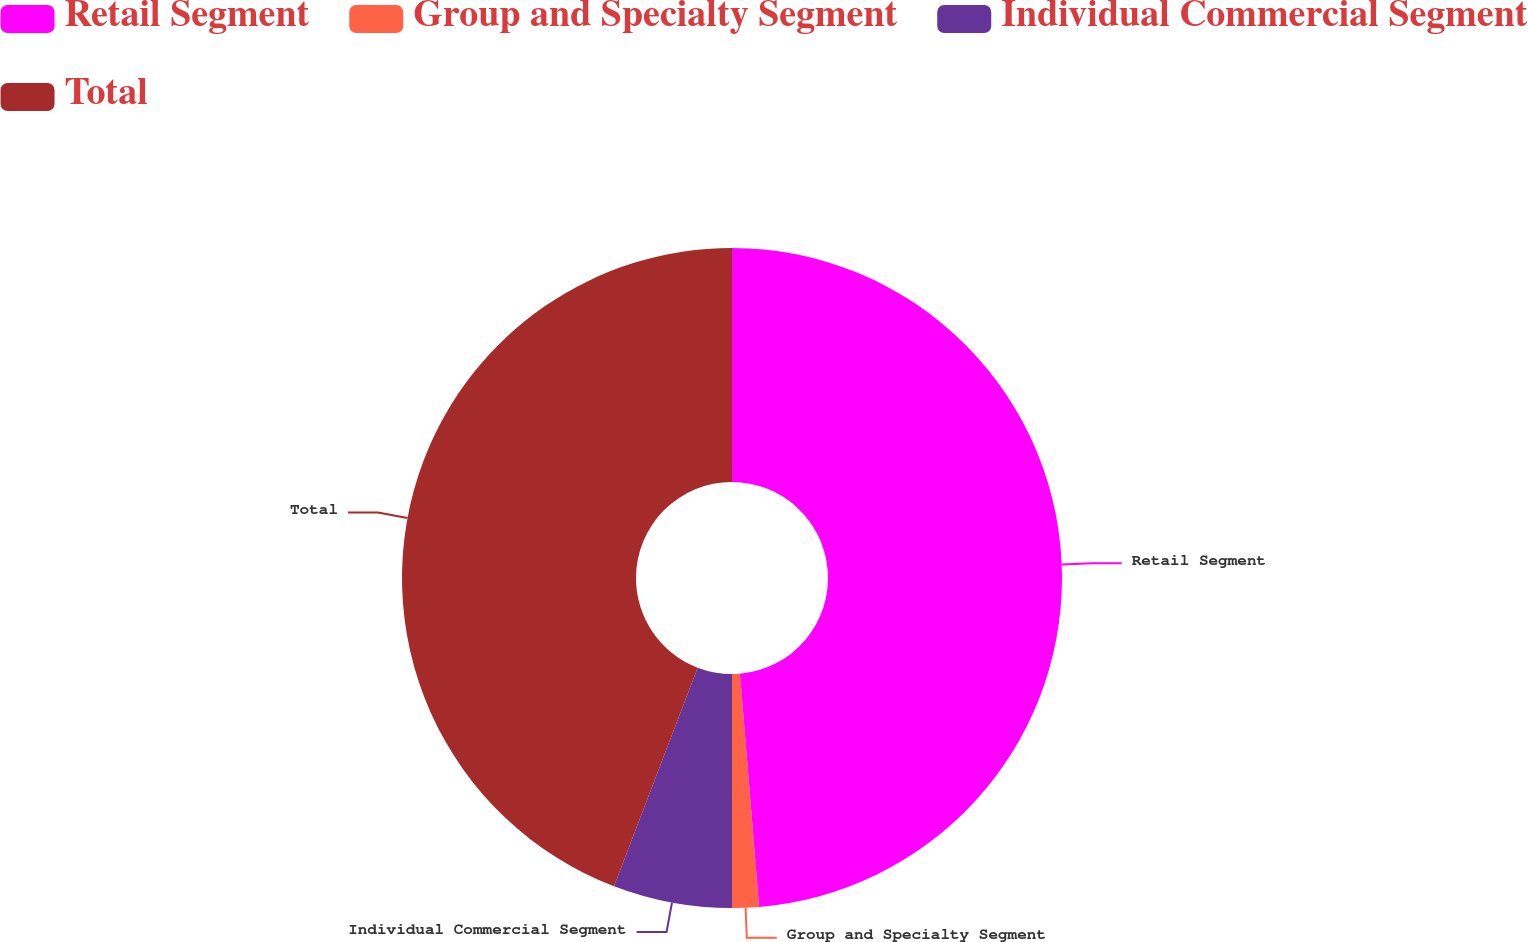Convert chart. <chart><loc_0><loc_0><loc_500><loc_500><pie_chart><fcel>Retail Segment<fcel>Group and Specialty Segment<fcel>Individual Commercial Segment<fcel>Total<nl><fcel>48.69%<fcel>1.31%<fcel>5.82%<fcel>44.18%<nl></chart> 